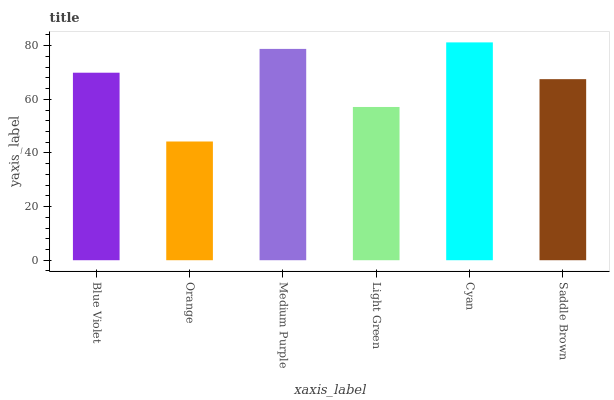Is Orange the minimum?
Answer yes or no. Yes. Is Cyan the maximum?
Answer yes or no. Yes. Is Medium Purple the minimum?
Answer yes or no. No. Is Medium Purple the maximum?
Answer yes or no. No. Is Medium Purple greater than Orange?
Answer yes or no. Yes. Is Orange less than Medium Purple?
Answer yes or no. Yes. Is Orange greater than Medium Purple?
Answer yes or no. No. Is Medium Purple less than Orange?
Answer yes or no. No. Is Blue Violet the high median?
Answer yes or no. Yes. Is Saddle Brown the low median?
Answer yes or no. Yes. Is Orange the high median?
Answer yes or no. No. Is Light Green the low median?
Answer yes or no. No. 